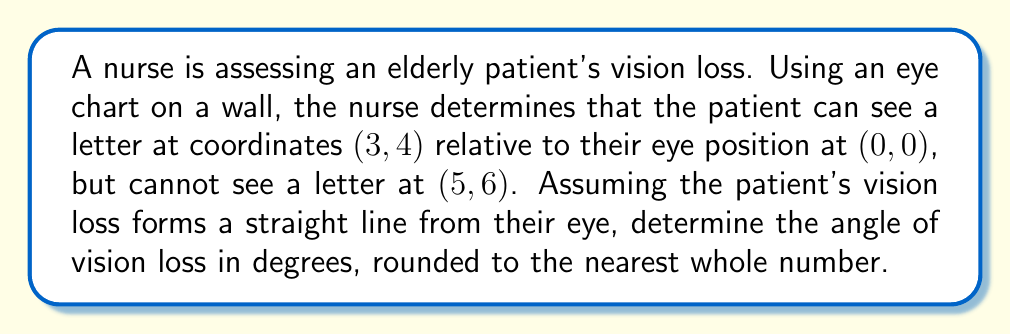Show me your answer to this math problem. To solve this problem, we'll use the concept of slope and arctangent to find the angle. Here's a step-by-step approach:

1) First, we need to find the slope of the line representing the patient's vision limit. We can use the point-slope formula:

   $m = \frac{y_2 - y_1}{x_2 - x_1} = \frac{4 - 0}{3 - 0} = \frac{4}{3}$

2) The slope represents the tangent of the angle we're looking for. So, we can use the arctangent (inverse tangent) function to find the angle:

   $\theta = \arctan(m) = \arctan(\frac{4}{3})$

3) We need to convert this from radians to degrees:

   $\theta_{degrees} = \theta_{radians} \times \frac{180°}{\pi}$

4) Calculating this:

   $\theta_{degrees} = \arctan(\frac{4}{3}) \times \frac{180°}{\pi} \approx 53.13°$

5) Rounding to the nearest whole number:

   $\theta_{degrees} \approx 53°$

Therefore, the angle of vision loss is approximately 53°.

[asy]
unitsize(1cm);
draw((-1,0)--(6,0), arrow=Arrow(TeXHead));
draw((0,-1)--(0,7), arrow=Arrow(TeXHead));
dot((0,0));
dot((3,4));
dot((5,6));
draw((0,0)--(5,6.67), dashed);
label("(0,0)", (0,0), SW);
label("(3,4)", (3,4), NE);
label("(5,6)", (5,6), NE);
label("x", (6,0), E);
label("y", (0,7), N);
label("53°", (0.5,0.5), NE);
[/asy]
Answer: The angle of vision loss is approximately 53°. 